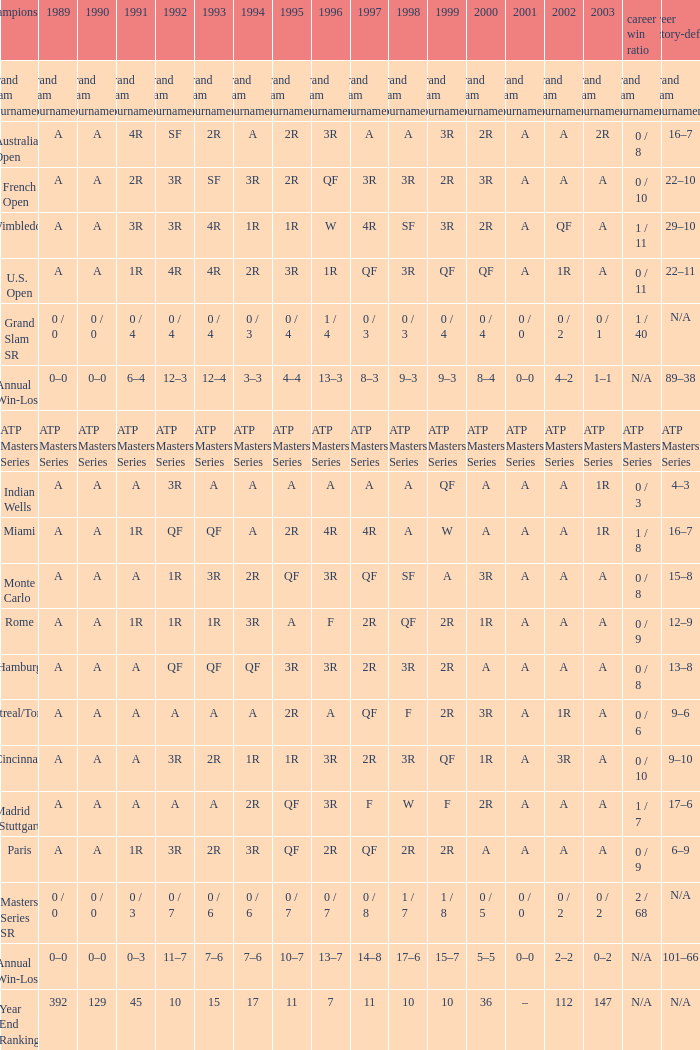What was the value in 1989 with QF in 1997 and A in 1993? A. Write the full table. {'header': ['championship', '1989', '1990', '1991', '1992', '1993', '1994', '1995', '1996', '1997', '1998', '1999', '2000', '2001', '2002', '2003', 'career win ratio', 'career victory-defeat'], 'rows': [['Grand Slam Tournaments', 'Grand Slam Tournaments', 'Grand Slam Tournaments', 'Grand Slam Tournaments', 'Grand Slam Tournaments', 'Grand Slam Tournaments', 'Grand Slam Tournaments', 'Grand Slam Tournaments', 'Grand Slam Tournaments', 'Grand Slam Tournaments', 'Grand Slam Tournaments', 'Grand Slam Tournaments', 'Grand Slam Tournaments', 'Grand Slam Tournaments', 'Grand Slam Tournaments', 'Grand Slam Tournaments', 'Grand Slam Tournaments', 'Grand Slam Tournaments'], ['Australian Open', 'A', 'A', '4R', 'SF', '2R', 'A', '2R', '3R', 'A', 'A', '3R', '2R', 'A', 'A', '2R', '0 / 8', '16–7'], ['French Open', 'A', 'A', '2R', '3R', 'SF', '3R', '2R', 'QF', '3R', '3R', '2R', '3R', 'A', 'A', 'A', '0 / 10', '22–10'], ['Wimbledon', 'A', 'A', '3R', '3R', '4R', '1R', '1R', 'W', '4R', 'SF', '3R', '2R', 'A', 'QF', 'A', '1 / 11', '29–10'], ['U.S. Open', 'A', 'A', '1R', '4R', '4R', '2R', '3R', '1R', 'QF', '3R', 'QF', 'QF', 'A', '1R', 'A', '0 / 11', '22–11'], ['Grand Slam SR', '0 / 0', '0 / 0', '0 / 4', '0 / 4', '0 / 4', '0 / 3', '0 / 4', '1 / 4', '0 / 3', '0 / 3', '0 / 4', '0 / 4', '0 / 0', '0 / 2', '0 / 1', '1 / 40', 'N/A'], ['Annual Win-Loss', '0–0', '0–0', '6–4', '12–3', '12–4', '3–3', '4–4', '13–3', '8–3', '9–3', '9–3', '8–4', '0–0', '4–2', '1–1', 'N/A', '89–38'], ['ATP Masters Series', 'ATP Masters Series', 'ATP Masters Series', 'ATP Masters Series', 'ATP Masters Series', 'ATP Masters Series', 'ATP Masters Series', 'ATP Masters Series', 'ATP Masters Series', 'ATP Masters Series', 'ATP Masters Series', 'ATP Masters Series', 'ATP Masters Series', 'ATP Masters Series', 'ATP Masters Series', 'ATP Masters Series', 'ATP Masters Series', 'ATP Masters Series'], ['Indian Wells', 'A', 'A', 'A', '3R', 'A', 'A', 'A', 'A', 'A', 'A', 'QF', 'A', 'A', 'A', '1R', '0 / 3', '4–3'], ['Miami', 'A', 'A', '1R', 'QF', 'QF', 'A', '2R', '4R', '4R', 'A', 'W', 'A', 'A', 'A', '1R', '1 / 8', '16–7'], ['Monte Carlo', 'A', 'A', 'A', '1R', '3R', '2R', 'QF', '3R', 'QF', 'SF', 'A', '3R', 'A', 'A', 'A', '0 / 8', '15–8'], ['Rome', 'A', 'A', '1R', '1R', '1R', '3R', 'A', 'F', '2R', 'QF', '2R', '1R', 'A', 'A', 'A', '0 / 9', '12–9'], ['Hamburg', 'A', 'A', 'A', 'QF', 'QF', 'QF', '3R', '3R', '2R', '3R', '2R', 'A', 'A', 'A', 'A', '0 / 8', '13–8'], ['Montreal/Toronto', 'A', 'A', 'A', 'A', 'A', 'A', '2R', 'A', 'QF', 'F', '2R', '3R', 'A', '1R', 'A', '0 / 6', '9–6'], ['Cincinnati', 'A', 'A', 'A', '3R', '2R', '1R', '1R', '3R', '2R', '3R', 'QF', '1R', 'A', '3R', 'A', '0 / 10', '9–10'], ['Madrid (Stuttgart)', 'A', 'A', 'A', 'A', 'A', '2R', 'QF', '3R', 'F', 'W', 'F', '2R', 'A', 'A', 'A', '1 / 7', '17–6'], ['Paris', 'A', 'A', '1R', '3R', '2R', '3R', 'QF', '2R', 'QF', '2R', '2R', 'A', 'A', 'A', 'A', '0 / 9', '6–9'], ['Masters Series SR', '0 / 0', '0 / 0', '0 / 3', '0 / 7', '0 / 6', '0 / 6', '0 / 7', '0 / 7', '0 / 8', '1 / 7', '1 / 8', '0 / 5', '0 / 0', '0 / 2', '0 / 2', '2 / 68', 'N/A'], ['Annual Win-Loss', '0–0', '0–0', '0–3', '11–7', '7–6', '7–6', '10–7', '13–7', '14–8', '17–6', '15–7', '5–5', '0–0', '2–2', '0–2', 'N/A', '101–66'], ['Year End Ranking', '392', '129', '45', '10', '15', '17', '11', '7', '11', '10', '10', '36', '–', '112', '147', 'N/A', 'N/A']]} 